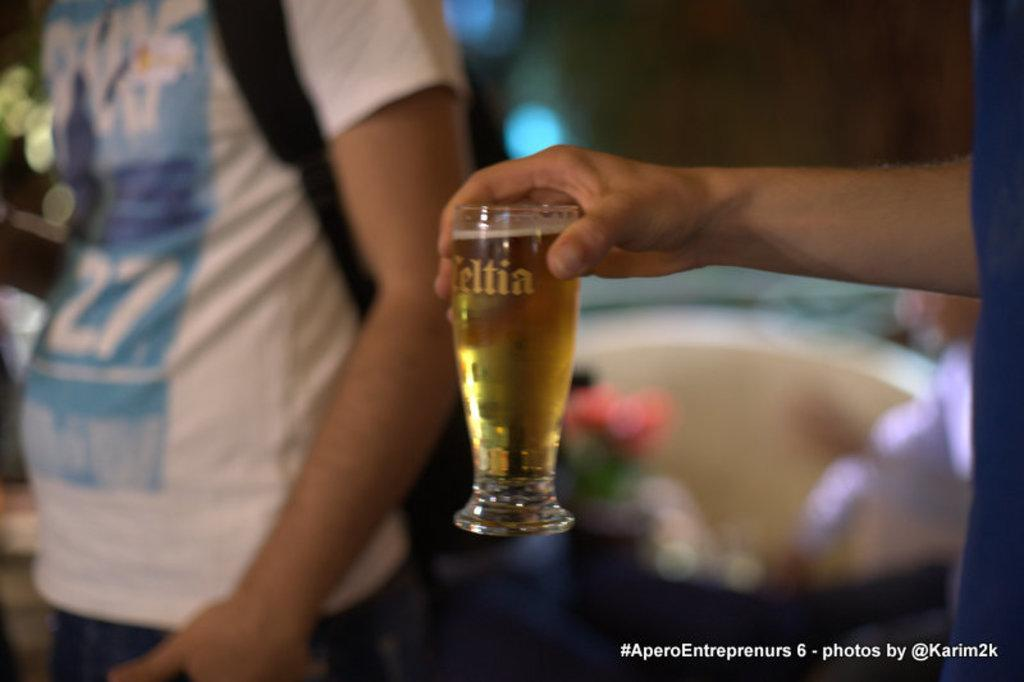What is the person in the image holding? The person is holding a glass with a drink. Can you describe the person in the image? There is only one person in the image, but no specific details about their appearance are provided. What additional feature can be seen in the image? There is a watermark in the image. How would you describe the background of the image? The background of the image is blurred. What type of brush is being used to create the sand art in the image? There is no brush or sand art present in the image; it features a person holding a glass with a drink and a blurred background. 